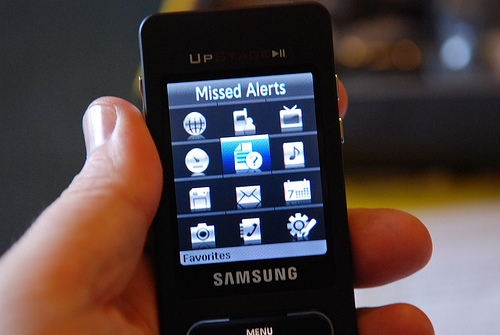Can you describe the setting or context in which this photo was taken? Although the background is out of focus, it appears to be an indoor setting with soft lighting. The main focus is on the hand holding the device, which suggests the photo was taken to highlight the phone, perhaps for personal use, selling, or sharing information about the phone. 